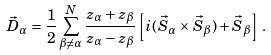<formula> <loc_0><loc_0><loc_500><loc_500>\vec { D } _ { \alpha } = \frac { 1 } { 2 } \sum _ { \beta \neq \alpha } ^ { N } \frac { z _ { \alpha } + z _ { \beta } } { z _ { \alpha } - z _ { \beta } } \left [ i ( \vec { S } _ { \alpha } \times \vec { S } _ { \beta } ) + \vec { S } _ { \beta } \right ] \, .</formula> 